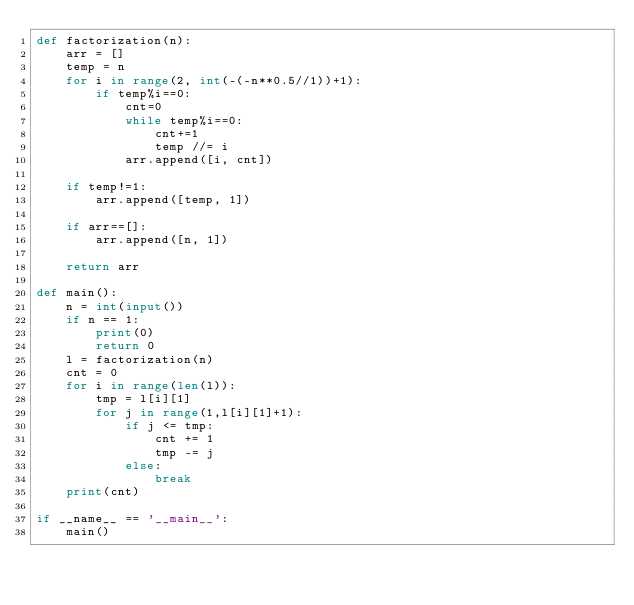Convert code to text. <code><loc_0><loc_0><loc_500><loc_500><_Python_>def factorization(n):
    arr = []
    temp = n
    for i in range(2, int(-(-n**0.5//1))+1):
        if temp%i==0:
            cnt=0
            while temp%i==0:
                cnt+=1
                temp //= i
            arr.append([i, cnt])

    if temp!=1:
        arr.append([temp, 1])

    if arr==[]:
        arr.append([n, 1])

    return arr

def main():
    n = int(input())
    if n == 1:
        print(0)
        return 0
    l = factorization(n)
    cnt = 0
    for i in range(len(l)):
        tmp = l[i][1]
        for j in range(1,l[i][1]+1):
            if j <= tmp:
                cnt += 1
                tmp -= j
            else:
                break
    print(cnt)

if __name__ == '__main__':
    main()



</code> 